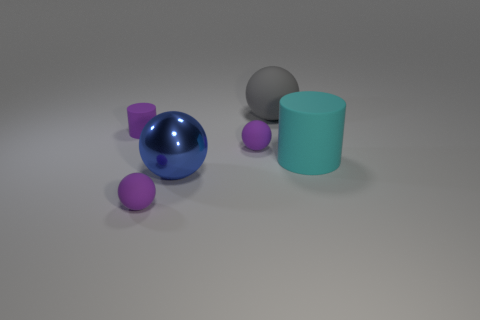Are there any small purple cylinders made of the same material as the big cyan cylinder?
Provide a short and direct response. Yes. What color is the large object on the right side of the gray matte thing?
Offer a very short reply. Cyan. There is a large gray matte thing; does it have the same shape as the blue shiny thing that is on the right side of the small purple cylinder?
Provide a short and direct response. Yes. Are there any small objects of the same color as the tiny matte cylinder?
Keep it short and to the point. Yes. What is the size of the purple cylinder that is made of the same material as the gray object?
Make the answer very short. Small. Is the shape of the large object that is on the left side of the large gray matte object the same as  the gray rubber thing?
Your answer should be compact. Yes. How many cyan metal cylinders have the same size as the blue object?
Offer a terse response. 0. Are there any purple spheres behind the matte thing in front of the large cyan thing?
Ensure brevity in your answer.  Yes. How many objects are either balls in front of the tiny purple cylinder or big cyan rubber cylinders?
Keep it short and to the point. 4. What number of tiny things are there?
Offer a very short reply. 3. 